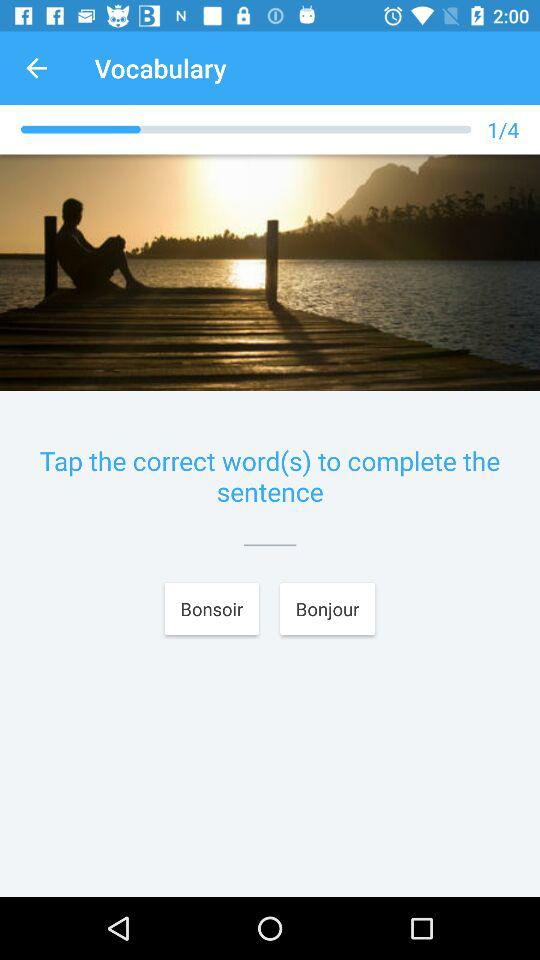How many total vocabularies are there? There are a total of 4 vocabularies. 